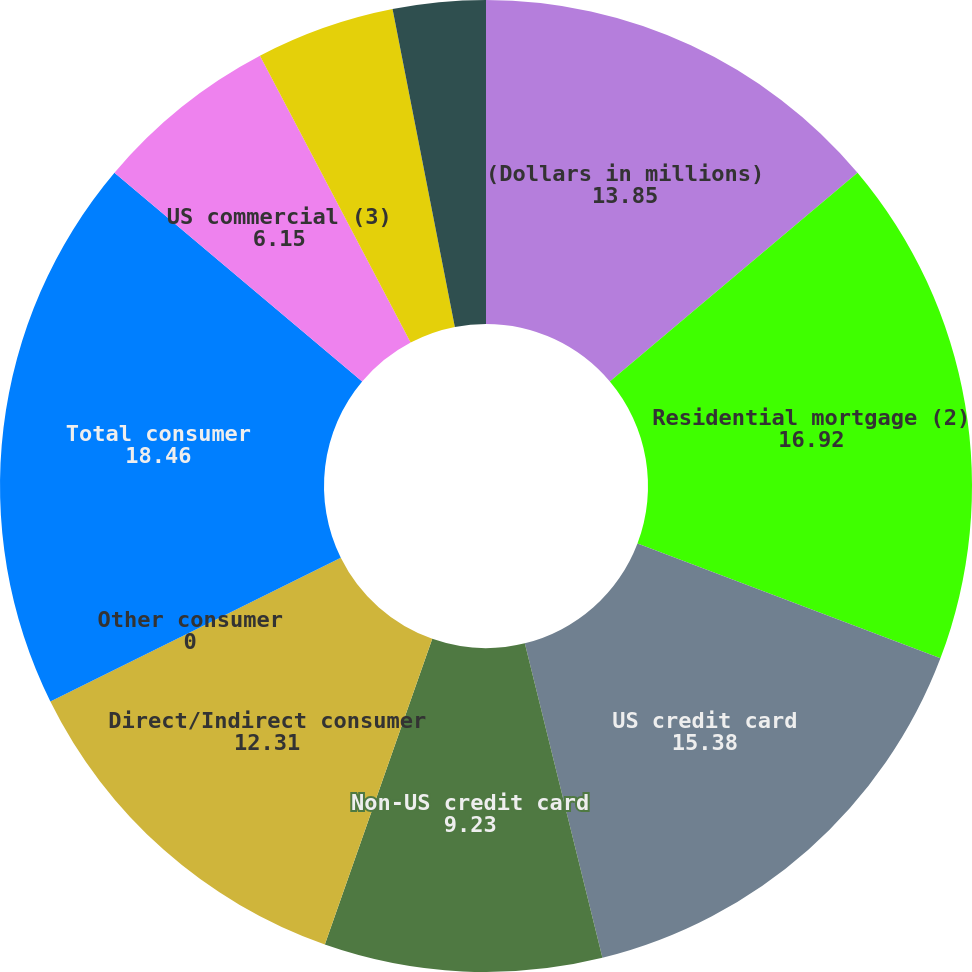Convert chart to OTSL. <chart><loc_0><loc_0><loc_500><loc_500><pie_chart><fcel>(Dollars in millions)<fcel>Residential mortgage (2)<fcel>US credit card<fcel>Non-US credit card<fcel>Direct/Indirect consumer<fcel>Other consumer<fcel>Total consumer<fcel>US commercial (3)<fcel>Commercial real estate<fcel>Commercial lease financing<nl><fcel>13.85%<fcel>16.92%<fcel>15.38%<fcel>9.23%<fcel>12.31%<fcel>0.0%<fcel>18.46%<fcel>6.15%<fcel>4.62%<fcel>3.08%<nl></chart> 